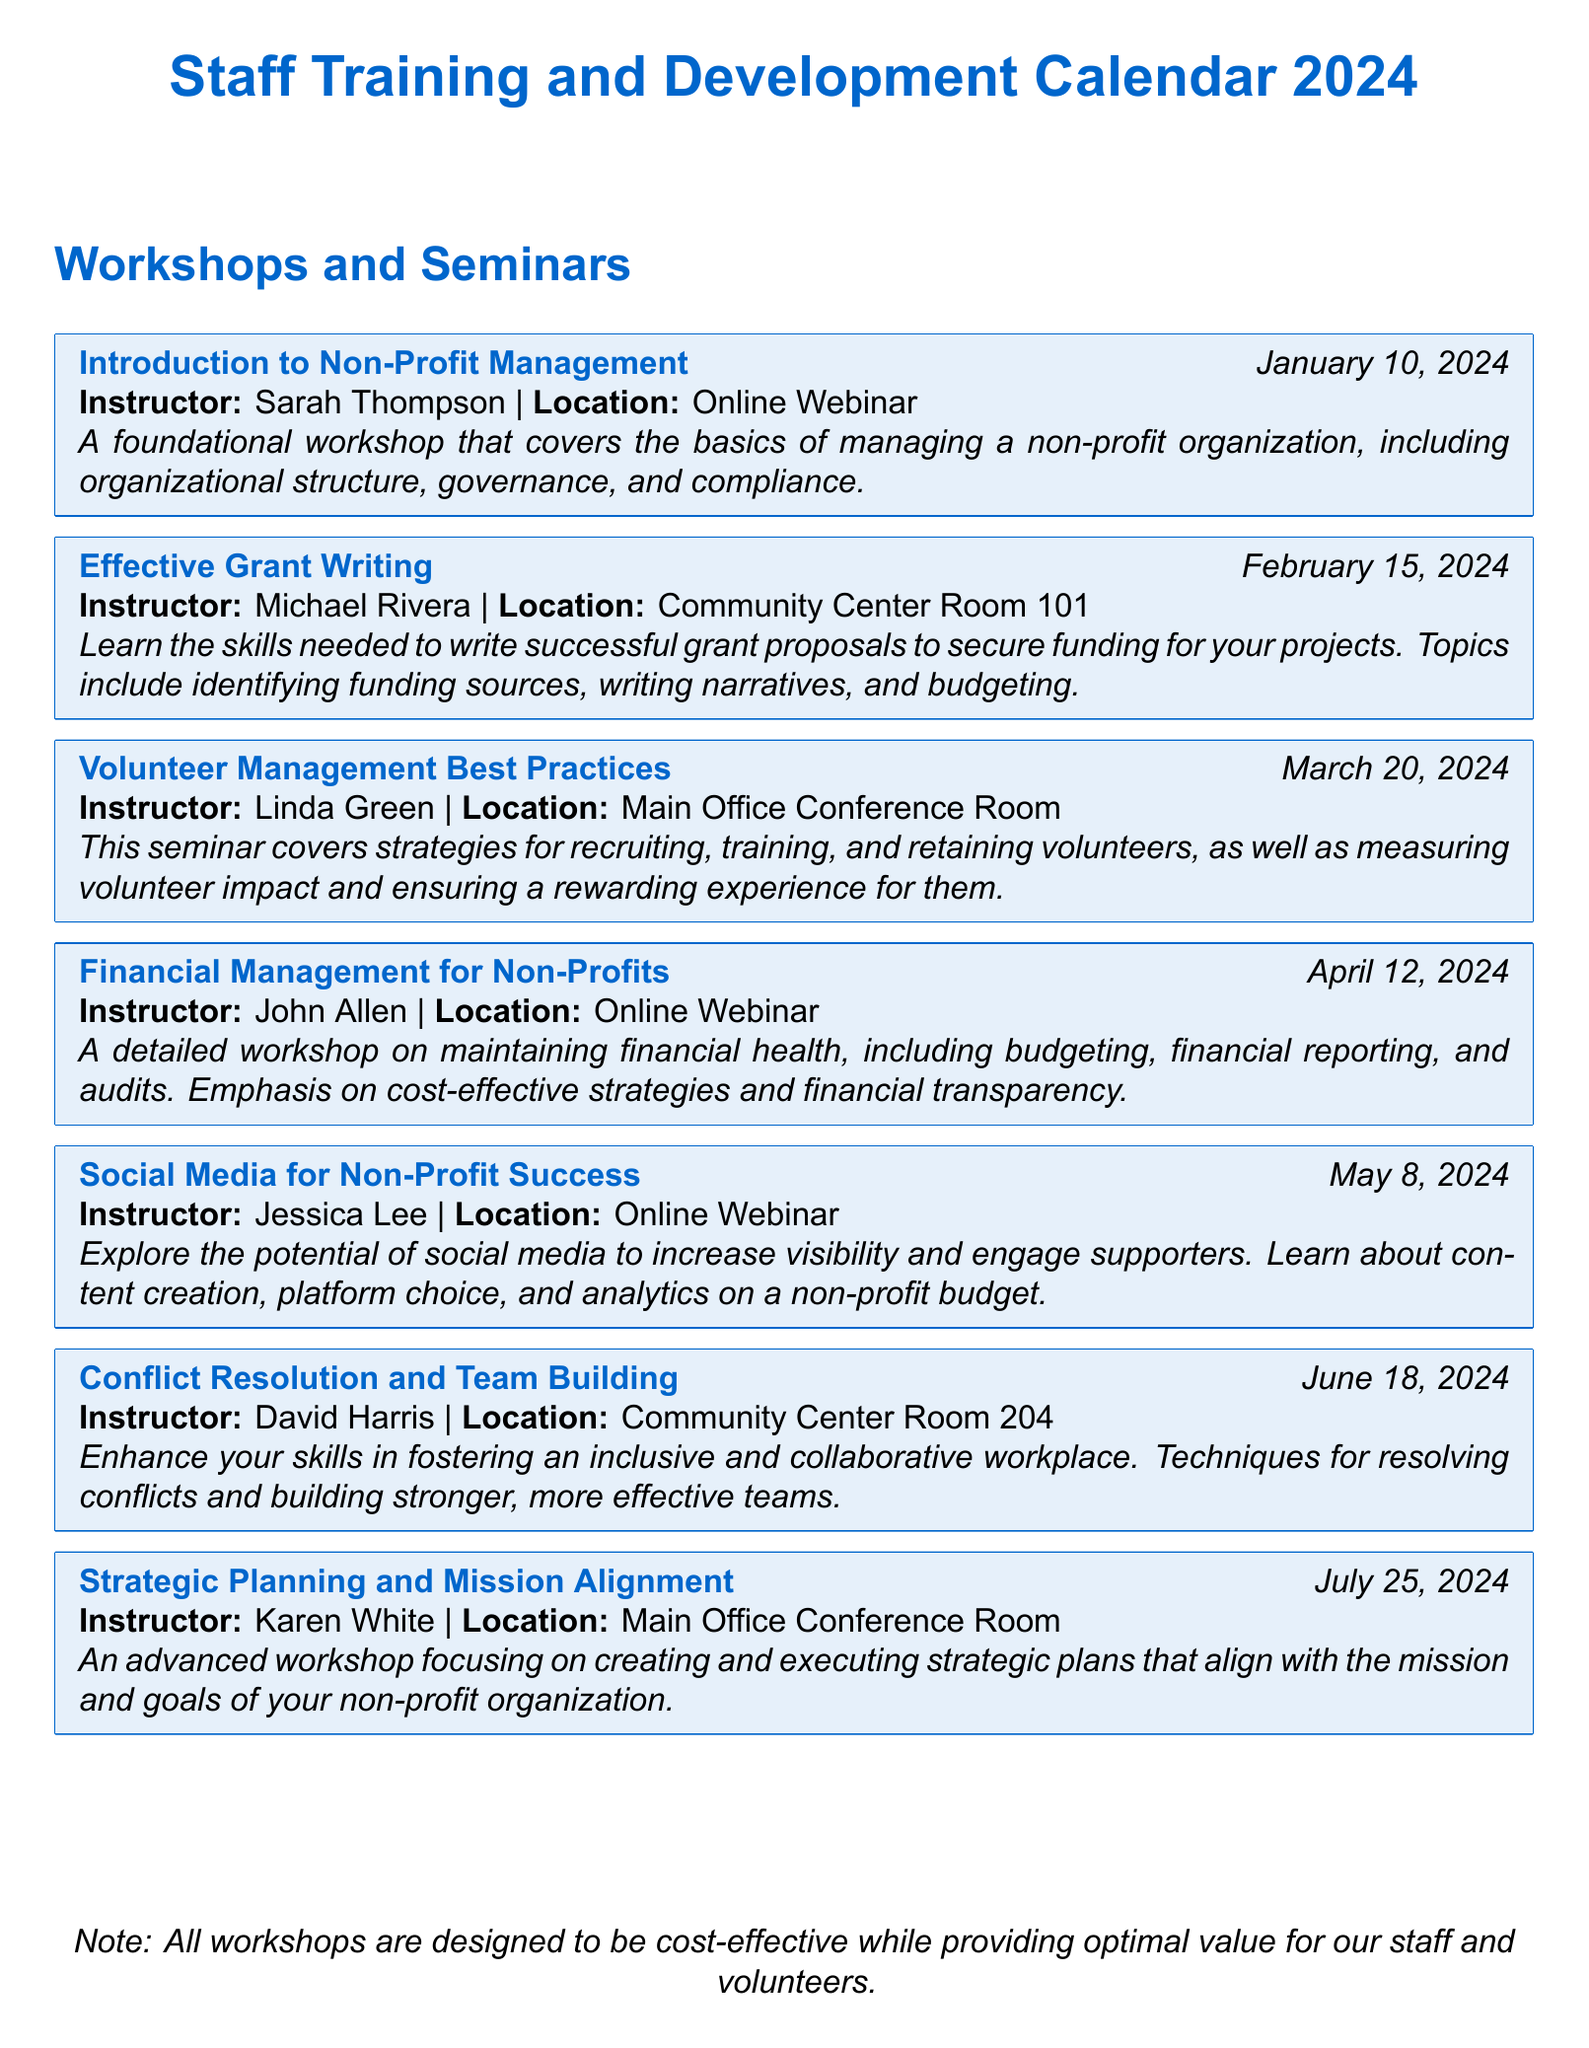What is the date of the "Effective Grant Writing" workshop? The date is stated as February 15, 2024.
Answer: February 15, 2024 Who is the instructor for the "Social Media for Non-Profit Success" workshop? The instructor is specified as Jessica Lee in the document.
Answer: Jessica Lee Where will the "Financial Management for Non-Profits" workshop be held? The location is given as an Online Webinar.
Answer: Online Webinar What is the primary focus of the "Volunteer Management Best Practices" seminar? The document describes it as covering strategies for recruiting, training, and retaining volunteers.
Answer: Recruiting, training, and retaining volunteers How many workshops are scheduled in the first half of the year? The document lists three workshops before July, which indicates the number of events in the first half of the year.
Answer: 3 Which workshop discusses strategic planning? The title provided for the workshop is "Strategic Planning and Mission Alignment."
Answer: Strategic Planning and Mission Alignment What type of venue hosts the "Conflict Resolution and Team Building" seminar? The venue type is mentioned as Community Center Room 204.
Answer: Community Center Room 204 What is the overall intention behind the workshops as noted in the document? The note specifies they are designed to be cost-effective while providing optimal value.
Answer: Cost-effective while providing optimal value 